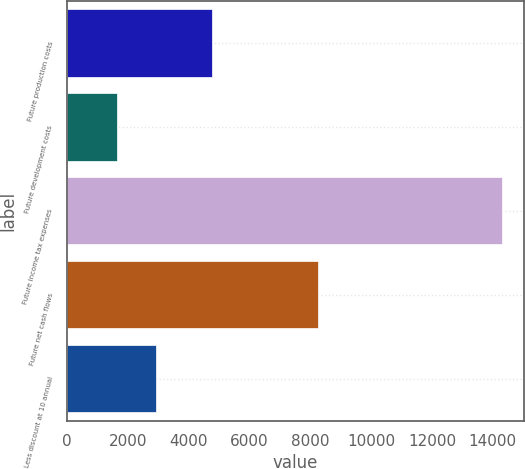<chart> <loc_0><loc_0><loc_500><loc_500><bar_chart><fcel>Future production costs<fcel>Future development costs<fcel>Future income tax expenses<fcel>Future net cash flows<fcel>Less discount at 10 annual<nl><fcel>4770<fcel>1640<fcel>14309<fcel>8241<fcel>2906.9<nl></chart> 